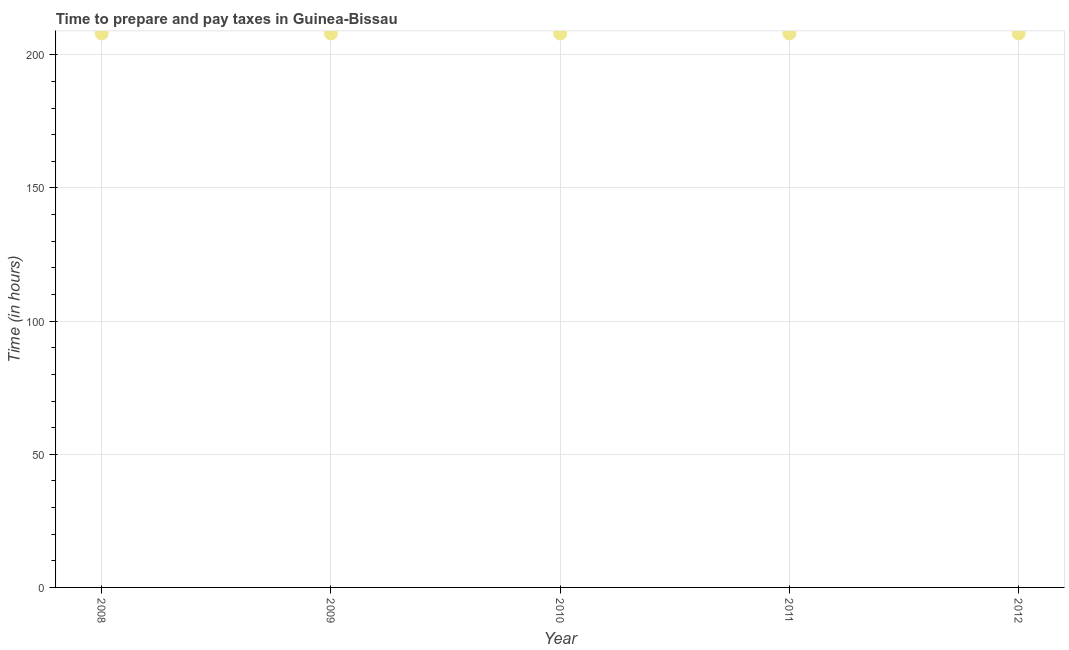What is the time to prepare and pay taxes in 2011?
Offer a terse response. 208. Across all years, what is the maximum time to prepare and pay taxes?
Provide a succinct answer. 208. Across all years, what is the minimum time to prepare and pay taxes?
Provide a short and direct response. 208. What is the sum of the time to prepare and pay taxes?
Provide a short and direct response. 1040. What is the difference between the time to prepare and pay taxes in 2010 and 2011?
Make the answer very short. 0. What is the average time to prepare and pay taxes per year?
Provide a short and direct response. 208. What is the median time to prepare and pay taxes?
Provide a short and direct response. 208. Is the difference between the time to prepare and pay taxes in 2008 and 2012 greater than the difference between any two years?
Provide a short and direct response. Yes. What is the difference between the highest and the second highest time to prepare and pay taxes?
Offer a terse response. 0. Is the sum of the time to prepare and pay taxes in 2009 and 2011 greater than the maximum time to prepare and pay taxes across all years?
Provide a short and direct response. Yes. What is the difference between the highest and the lowest time to prepare and pay taxes?
Ensure brevity in your answer.  0. Does the time to prepare and pay taxes monotonically increase over the years?
Provide a short and direct response. No. How many dotlines are there?
Ensure brevity in your answer.  1. How many years are there in the graph?
Provide a short and direct response. 5. What is the difference between two consecutive major ticks on the Y-axis?
Your response must be concise. 50. Are the values on the major ticks of Y-axis written in scientific E-notation?
Offer a very short reply. No. Does the graph contain grids?
Offer a very short reply. Yes. What is the title of the graph?
Provide a short and direct response. Time to prepare and pay taxes in Guinea-Bissau. What is the label or title of the Y-axis?
Ensure brevity in your answer.  Time (in hours). What is the Time (in hours) in 2008?
Offer a very short reply. 208. What is the Time (in hours) in 2009?
Provide a succinct answer. 208. What is the Time (in hours) in 2010?
Your answer should be very brief. 208. What is the Time (in hours) in 2011?
Give a very brief answer. 208. What is the Time (in hours) in 2012?
Provide a succinct answer. 208. What is the difference between the Time (in hours) in 2008 and 2009?
Offer a terse response. 0. What is the difference between the Time (in hours) in 2009 and 2010?
Ensure brevity in your answer.  0. What is the ratio of the Time (in hours) in 2008 to that in 2010?
Offer a terse response. 1. What is the ratio of the Time (in hours) in 2008 to that in 2012?
Provide a short and direct response. 1. What is the ratio of the Time (in hours) in 2010 to that in 2012?
Your answer should be very brief. 1. What is the ratio of the Time (in hours) in 2011 to that in 2012?
Keep it short and to the point. 1. 